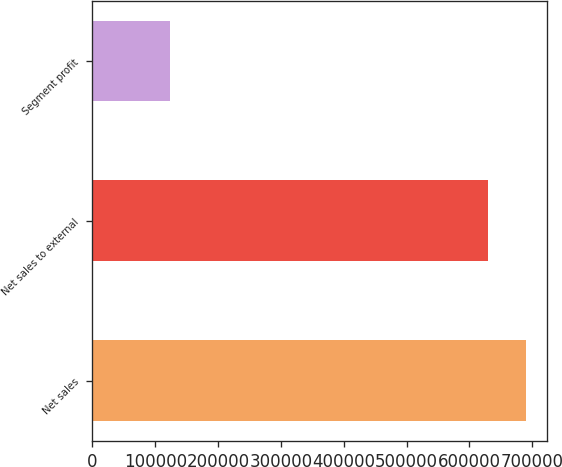Convert chart. <chart><loc_0><loc_0><loc_500><loc_500><bar_chart><fcel>Net sales<fcel>Net sales to external<fcel>Segment profit<nl><fcel>689546<fcel>628699<fcel>123384<nl></chart> 